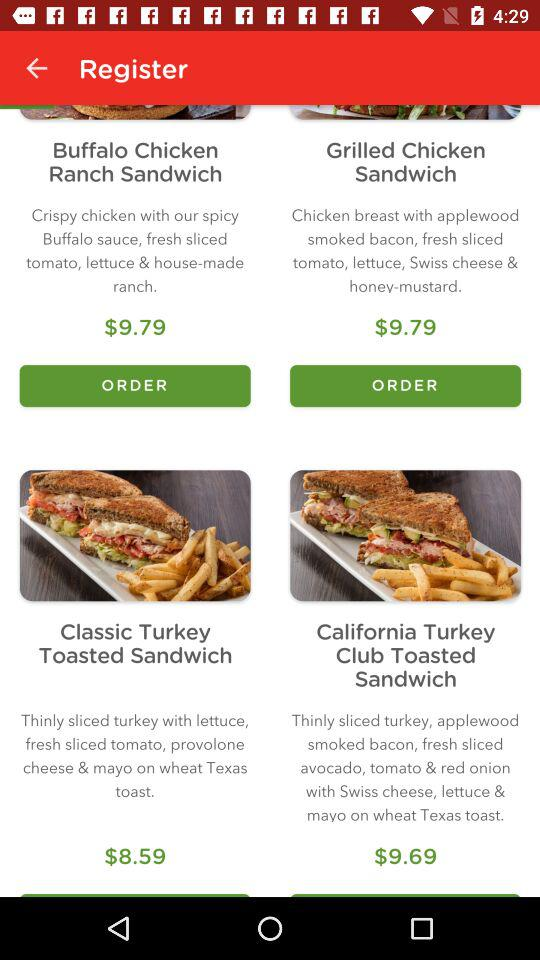What's the price of the Buffalo Chicken Ranch Sandwich? The price of the Buffalo Chicken Ranch Sandwich is $9.79. 